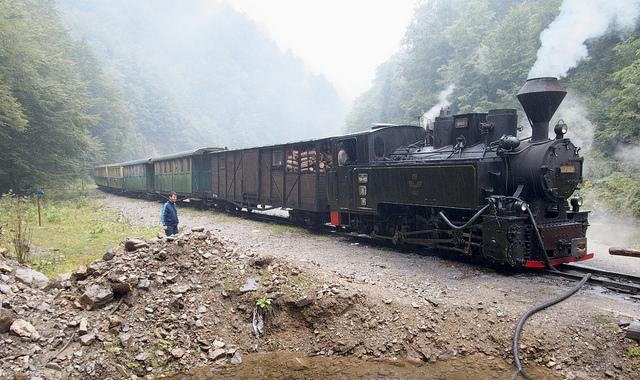Is one end of the hose in the water?
Quick response, please. Yes. Is this train emitting smoke?
Concise answer only. Yes. How many people are standing next to the train?
Concise answer only. 1. 